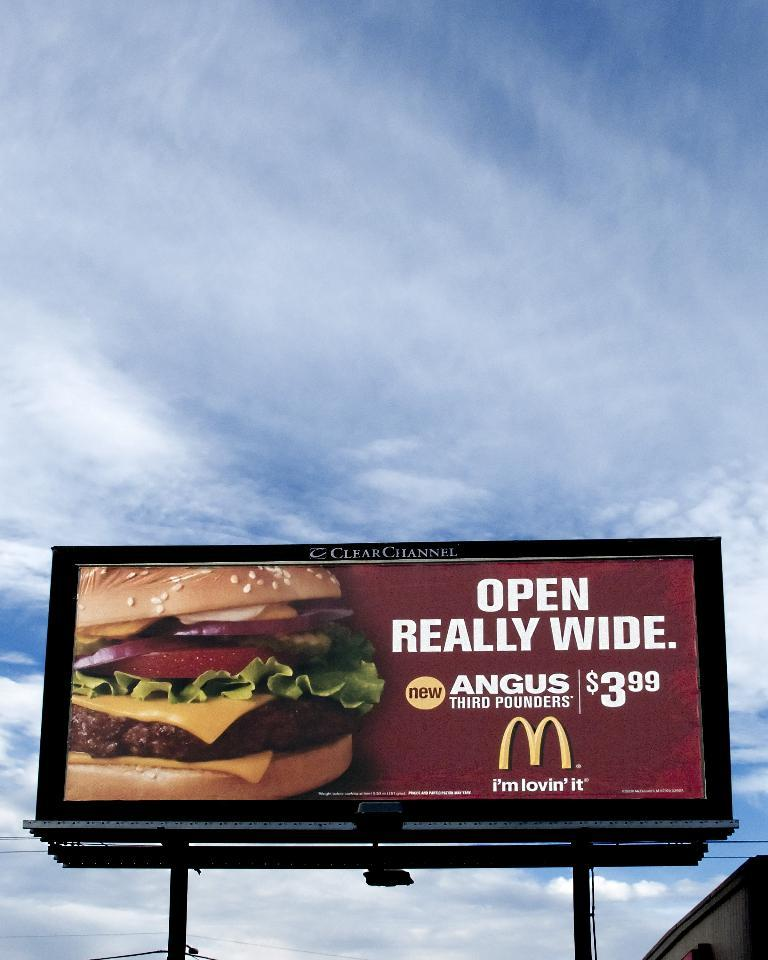<image>
Provide a brief description of the given image. A billboard for McDonald's advertising the angus third pounder. 